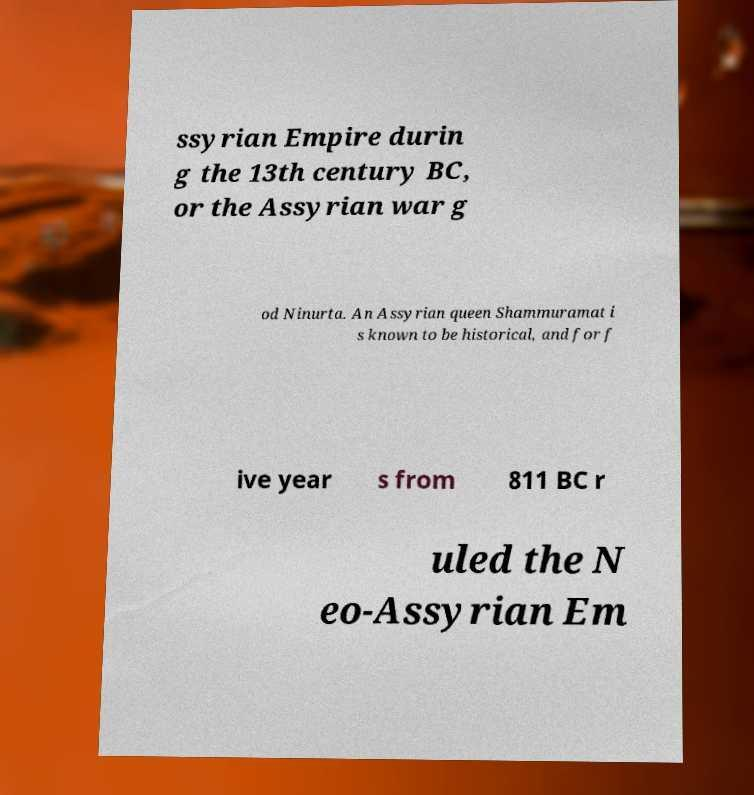Please read and relay the text visible in this image. What does it say? ssyrian Empire durin g the 13th century BC, or the Assyrian war g od Ninurta. An Assyrian queen Shammuramat i s known to be historical, and for f ive year s from 811 BC r uled the N eo-Assyrian Em 